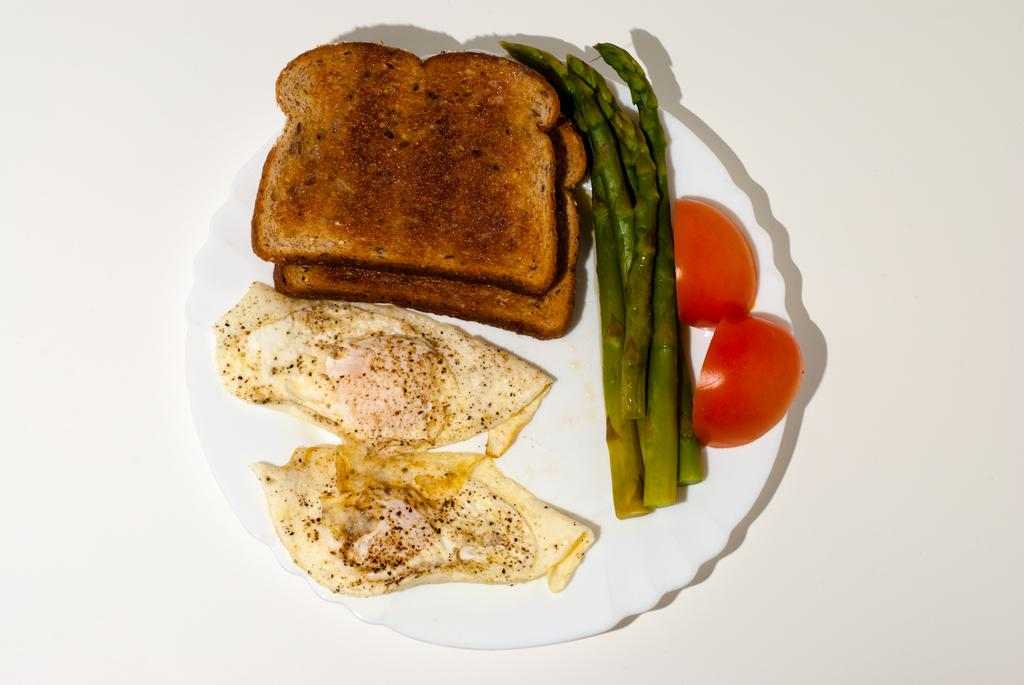What type of food can be seen in the image? There are omelettes, bread toasts, cooked beans, and tomato slices in the image. How are these food items arranged in the image? All of these food items are served on a plate. Can you describe the different types of food items in the image? There are omelettes, bread toasts, cooked beans, and tomato slices in the image. What color is the cherry on top of the omelette in the image? There is no cherry present on top of the omelette in the image. 